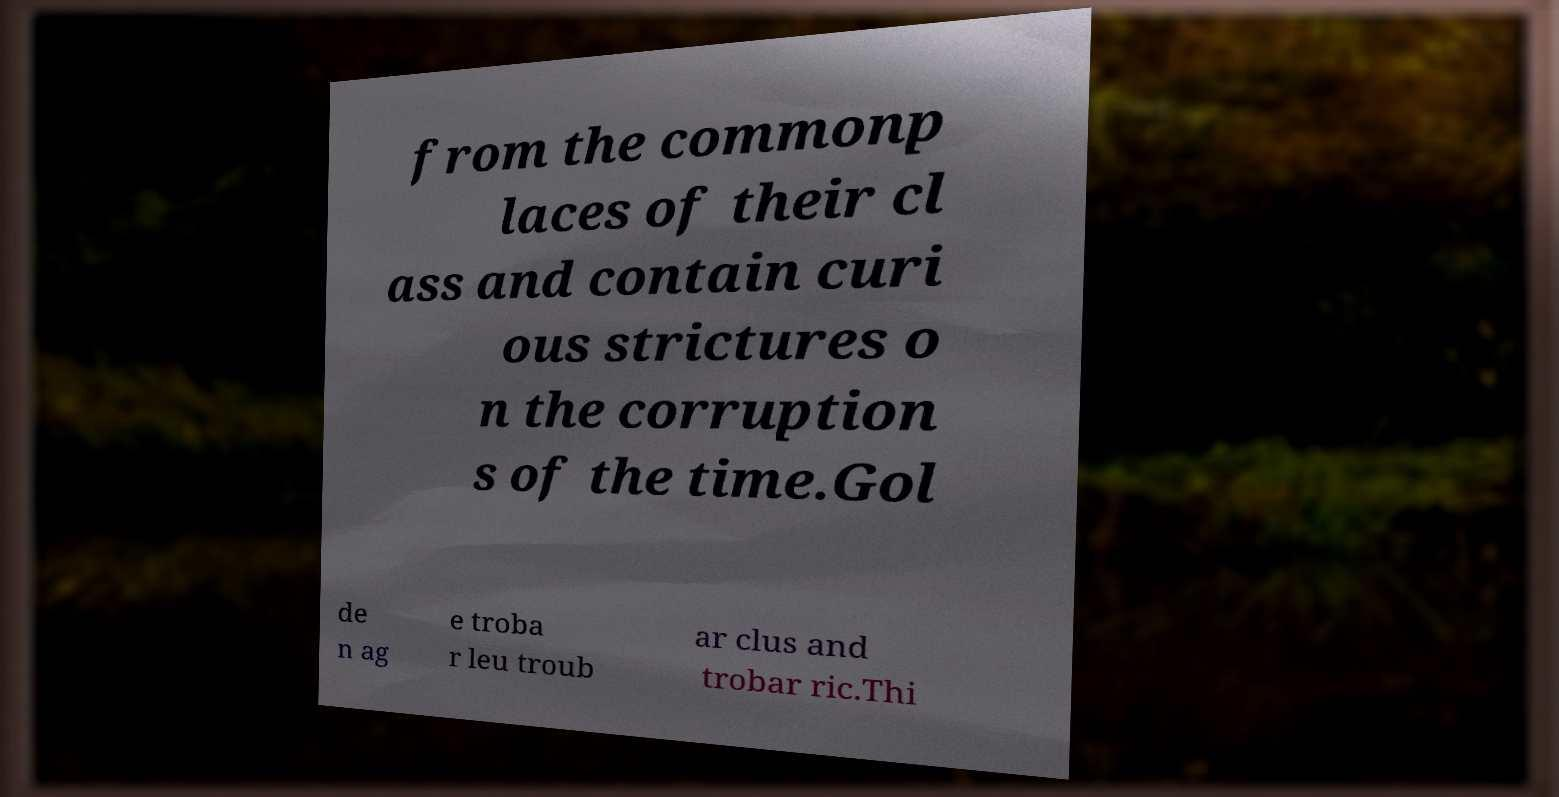For documentation purposes, I need the text within this image transcribed. Could you provide that? from the commonp laces of their cl ass and contain curi ous strictures o n the corruption s of the time.Gol de n ag e troba r leu troub ar clus and trobar ric.Thi 